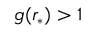<formula> <loc_0><loc_0><loc_500><loc_500>g ( r _ { * } ) > 1</formula> 